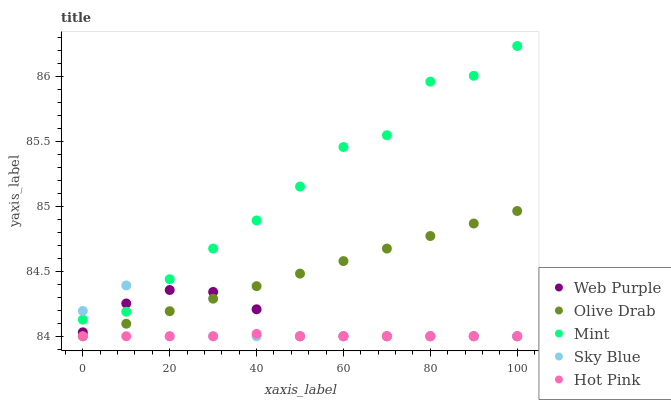Does Hot Pink have the minimum area under the curve?
Answer yes or no. Yes. Does Mint have the maximum area under the curve?
Answer yes or no. Yes. Does Web Purple have the minimum area under the curve?
Answer yes or no. No. Does Web Purple have the maximum area under the curve?
Answer yes or no. No. Is Olive Drab the smoothest?
Answer yes or no. Yes. Is Mint the roughest?
Answer yes or no. Yes. Is Web Purple the smoothest?
Answer yes or no. No. Is Web Purple the roughest?
Answer yes or no. No. Does Sky Blue have the lowest value?
Answer yes or no. Yes. Does Mint have the lowest value?
Answer yes or no. No. Does Mint have the highest value?
Answer yes or no. Yes. Does Web Purple have the highest value?
Answer yes or no. No. Is Hot Pink less than Mint?
Answer yes or no. Yes. Is Mint greater than Hot Pink?
Answer yes or no. Yes. Does Sky Blue intersect Hot Pink?
Answer yes or no. Yes. Is Sky Blue less than Hot Pink?
Answer yes or no. No. Is Sky Blue greater than Hot Pink?
Answer yes or no. No. Does Hot Pink intersect Mint?
Answer yes or no. No. 